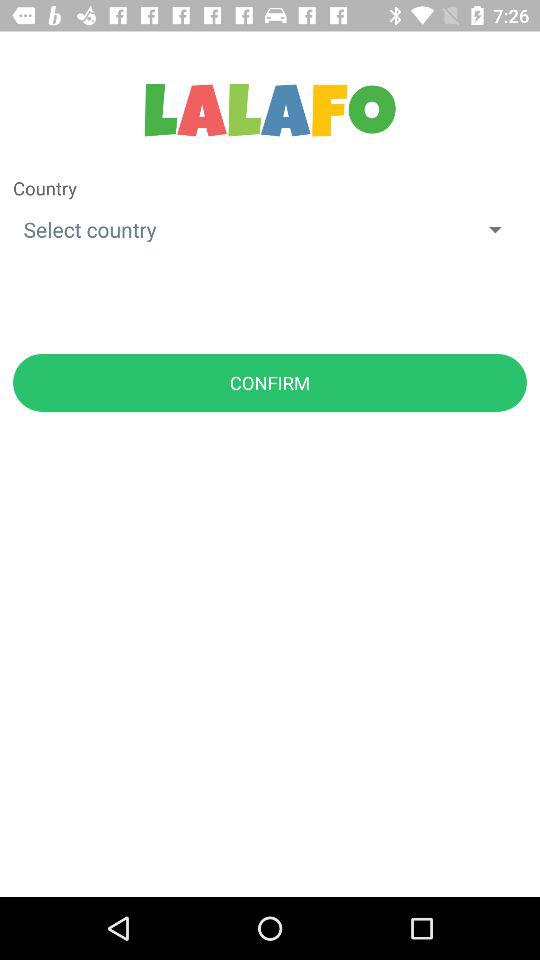What is the application name? The application name is "LALAFO". 